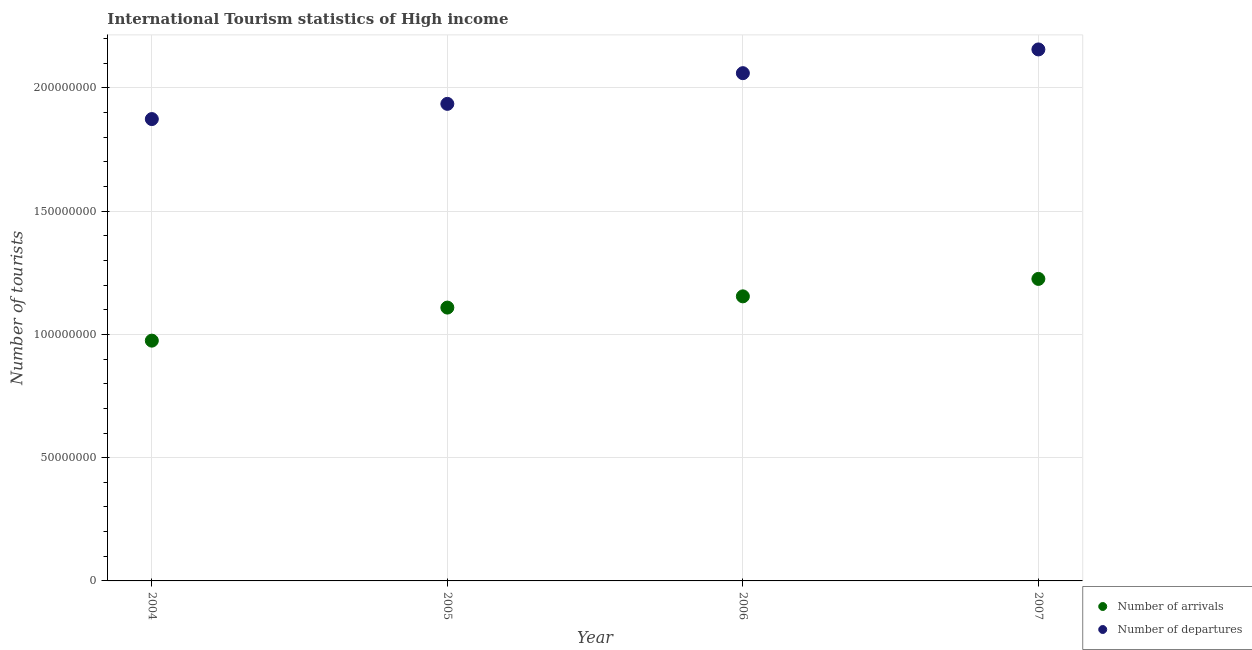How many different coloured dotlines are there?
Give a very brief answer. 2. Is the number of dotlines equal to the number of legend labels?
Your answer should be very brief. Yes. What is the number of tourist arrivals in 2005?
Keep it short and to the point. 1.11e+08. Across all years, what is the maximum number of tourist departures?
Offer a very short reply. 2.16e+08. Across all years, what is the minimum number of tourist departures?
Provide a succinct answer. 1.87e+08. In which year was the number of tourist arrivals maximum?
Offer a very short reply. 2007. What is the total number of tourist departures in the graph?
Offer a very short reply. 8.03e+08. What is the difference between the number of tourist arrivals in 2004 and that in 2005?
Your answer should be very brief. -1.34e+07. What is the difference between the number of tourist departures in 2007 and the number of tourist arrivals in 2006?
Keep it short and to the point. 1.00e+08. What is the average number of tourist arrivals per year?
Your response must be concise. 1.12e+08. In the year 2007, what is the difference between the number of tourist departures and number of tourist arrivals?
Offer a very short reply. 9.31e+07. What is the ratio of the number of tourist departures in 2005 to that in 2007?
Your answer should be very brief. 0.9. Is the number of tourist departures in 2005 less than that in 2006?
Provide a succinct answer. Yes. Is the difference between the number of tourist departures in 2004 and 2005 greater than the difference between the number of tourist arrivals in 2004 and 2005?
Provide a short and direct response. Yes. What is the difference between the highest and the second highest number of tourist arrivals?
Your response must be concise. 7.08e+06. What is the difference between the highest and the lowest number of tourist arrivals?
Provide a succinct answer. 2.50e+07. Does the number of tourist departures monotonically increase over the years?
Give a very brief answer. Yes. Is the number of tourist arrivals strictly less than the number of tourist departures over the years?
Your answer should be compact. Yes. How many dotlines are there?
Provide a succinct answer. 2. How many years are there in the graph?
Provide a short and direct response. 4. What is the difference between two consecutive major ticks on the Y-axis?
Provide a short and direct response. 5.00e+07. Are the values on the major ticks of Y-axis written in scientific E-notation?
Give a very brief answer. No. Does the graph contain grids?
Your response must be concise. Yes. How many legend labels are there?
Give a very brief answer. 2. How are the legend labels stacked?
Your answer should be compact. Vertical. What is the title of the graph?
Offer a very short reply. International Tourism statistics of High income. Does "Taxes on profits and capital gains" appear as one of the legend labels in the graph?
Your answer should be very brief. No. What is the label or title of the Y-axis?
Keep it short and to the point. Number of tourists. What is the Number of tourists in Number of arrivals in 2004?
Keep it short and to the point. 9.75e+07. What is the Number of tourists in Number of departures in 2004?
Offer a terse response. 1.87e+08. What is the Number of tourists of Number of arrivals in 2005?
Give a very brief answer. 1.11e+08. What is the Number of tourists in Number of departures in 2005?
Offer a very short reply. 1.94e+08. What is the Number of tourists of Number of arrivals in 2006?
Keep it short and to the point. 1.15e+08. What is the Number of tourists of Number of departures in 2006?
Offer a very short reply. 2.06e+08. What is the Number of tourists in Number of arrivals in 2007?
Offer a terse response. 1.23e+08. What is the Number of tourists in Number of departures in 2007?
Provide a short and direct response. 2.16e+08. Across all years, what is the maximum Number of tourists of Number of arrivals?
Offer a very short reply. 1.23e+08. Across all years, what is the maximum Number of tourists of Number of departures?
Ensure brevity in your answer.  2.16e+08. Across all years, what is the minimum Number of tourists in Number of arrivals?
Your answer should be compact. 9.75e+07. Across all years, what is the minimum Number of tourists of Number of departures?
Provide a short and direct response. 1.87e+08. What is the total Number of tourists in Number of arrivals in the graph?
Offer a terse response. 4.46e+08. What is the total Number of tourists in Number of departures in the graph?
Your response must be concise. 8.03e+08. What is the difference between the Number of tourists of Number of arrivals in 2004 and that in 2005?
Provide a succinct answer. -1.34e+07. What is the difference between the Number of tourists in Number of departures in 2004 and that in 2005?
Ensure brevity in your answer.  -6.17e+06. What is the difference between the Number of tourists in Number of arrivals in 2004 and that in 2006?
Your answer should be compact. -1.80e+07. What is the difference between the Number of tourists of Number of departures in 2004 and that in 2006?
Your answer should be compact. -1.86e+07. What is the difference between the Number of tourists of Number of arrivals in 2004 and that in 2007?
Keep it short and to the point. -2.50e+07. What is the difference between the Number of tourists of Number of departures in 2004 and that in 2007?
Ensure brevity in your answer.  -2.83e+07. What is the difference between the Number of tourists in Number of arrivals in 2005 and that in 2006?
Give a very brief answer. -4.56e+06. What is the difference between the Number of tourists of Number of departures in 2005 and that in 2006?
Make the answer very short. -1.25e+07. What is the difference between the Number of tourists in Number of arrivals in 2005 and that in 2007?
Offer a very short reply. -1.16e+07. What is the difference between the Number of tourists of Number of departures in 2005 and that in 2007?
Provide a short and direct response. -2.21e+07. What is the difference between the Number of tourists in Number of arrivals in 2006 and that in 2007?
Make the answer very short. -7.08e+06. What is the difference between the Number of tourists in Number of departures in 2006 and that in 2007?
Your response must be concise. -9.63e+06. What is the difference between the Number of tourists of Number of arrivals in 2004 and the Number of tourists of Number of departures in 2005?
Your answer should be very brief. -9.61e+07. What is the difference between the Number of tourists in Number of arrivals in 2004 and the Number of tourists in Number of departures in 2006?
Offer a very short reply. -1.09e+08. What is the difference between the Number of tourists in Number of arrivals in 2004 and the Number of tourists in Number of departures in 2007?
Ensure brevity in your answer.  -1.18e+08. What is the difference between the Number of tourists of Number of arrivals in 2005 and the Number of tourists of Number of departures in 2006?
Make the answer very short. -9.51e+07. What is the difference between the Number of tourists in Number of arrivals in 2005 and the Number of tourists in Number of departures in 2007?
Your response must be concise. -1.05e+08. What is the difference between the Number of tourists of Number of arrivals in 2006 and the Number of tourists of Number of departures in 2007?
Make the answer very short. -1.00e+08. What is the average Number of tourists of Number of arrivals per year?
Keep it short and to the point. 1.12e+08. What is the average Number of tourists in Number of departures per year?
Offer a very short reply. 2.01e+08. In the year 2004, what is the difference between the Number of tourists of Number of arrivals and Number of tourists of Number of departures?
Offer a terse response. -8.99e+07. In the year 2005, what is the difference between the Number of tourists of Number of arrivals and Number of tourists of Number of departures?
Your answer should be compact. -8.27e+07. In the year 2006, what is the difference between the Number of tourists of Number of arrivals and Number of tourists of Number of departures?
Offer a very short reply. -9.06e+07. In the year 2007, what is the difference between the Number of tourists in Number of arrivals and Number of tourists in Number of departures?
Provide a short and direct response. -9.31e+07. What is the ratio of the Number of tourists of Number of arrivals in 2004 to that in 2005?
Keep it short and to the point. 0.88. What is the ratio of the Number of tourists in Number of departures in 2004 to that in 2005?
Provide a succinct answer. 0.97. What is the ratio of the Number of tourists in Number of arrivals in 2004 to that in 2006?
Your answer should be compact. 0.84. What is the ratio of the Number of tourists in Number of departures in 2004 to that in 2006?
Provide a short and direct response. 0.91. What is the ratio of the Number of tourists of Number of arrivals in 2004 to that in 2007?
Provide a succinct answer. 0.8. What is the ratio of the Number of tourists of Number of departures in 2004 to that in 2007?
Make the answer very short. 0.87. What is the ratio of the Number of tourists of Number of arrivals in 2005 to that in 2006?
Offer a very short reply. 0.96. What is the ratio of the Number of tourists of Number of departures in 2005 to that in 2006?
Provide a succinct answer. 0.94. What is the ratio of the Number of tourists of Number of arrivals in 2005 to that in 2007?
Make the answer very short. 0.91. What is the ratio of the Number of tourists of Number of departures in 2005 to that in 2007?
Provide a short and direct response. 0.9. What is the ratio of the Number of tourists in Number of arrivals in 2006 to that in 2007?
Offer a very short reply. 0.94. What is the ratio of the Number of tourists in Number of departures in 2006 to that in 2007?
Your answer should be compact. 0.96. What is the difference between the highest and the second highest Number of tourists in Number of arrivals?
Keep it short and to the point. 7.08e+06. What is the difference between the highest and the second highest Number of tourists of Number of departures?
Give a very brief answer. 9.63e+06. What is the difference between the highest and the lowest Number of tourists in Number of arrivals?
Offer a terse response. 2.50e+07. What is the difference between the highest and the lowest Number of tourists in Number of departures?
Your answer should be compact. 2.83e+07. 